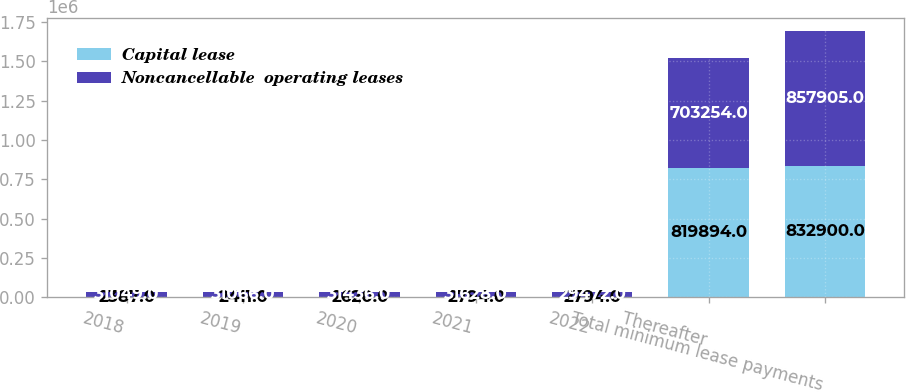Convert chart to OTSL. <chart><loc_0><loc_0><loc_500><loc_500><stacked_bar_chart><ecel><fcel>2018<fcel>2019<fcel>2020<fcel>2021<fcel>2022<fcel>Thereafter<fcel>Total minimum lease payments<nl><fcel>Capital lease<fcel>2387<fcel>2411<fcel>2620<fcel>2794<fcel>2794<fcel>819894<fcel>832900<nl><fcel>Noncancellable  operating leases<fcel>31049<fcel>31066<fcel>31436<fcel>31628<fcel>29472<fcel>703254<fcel>857905<nl></chart> 